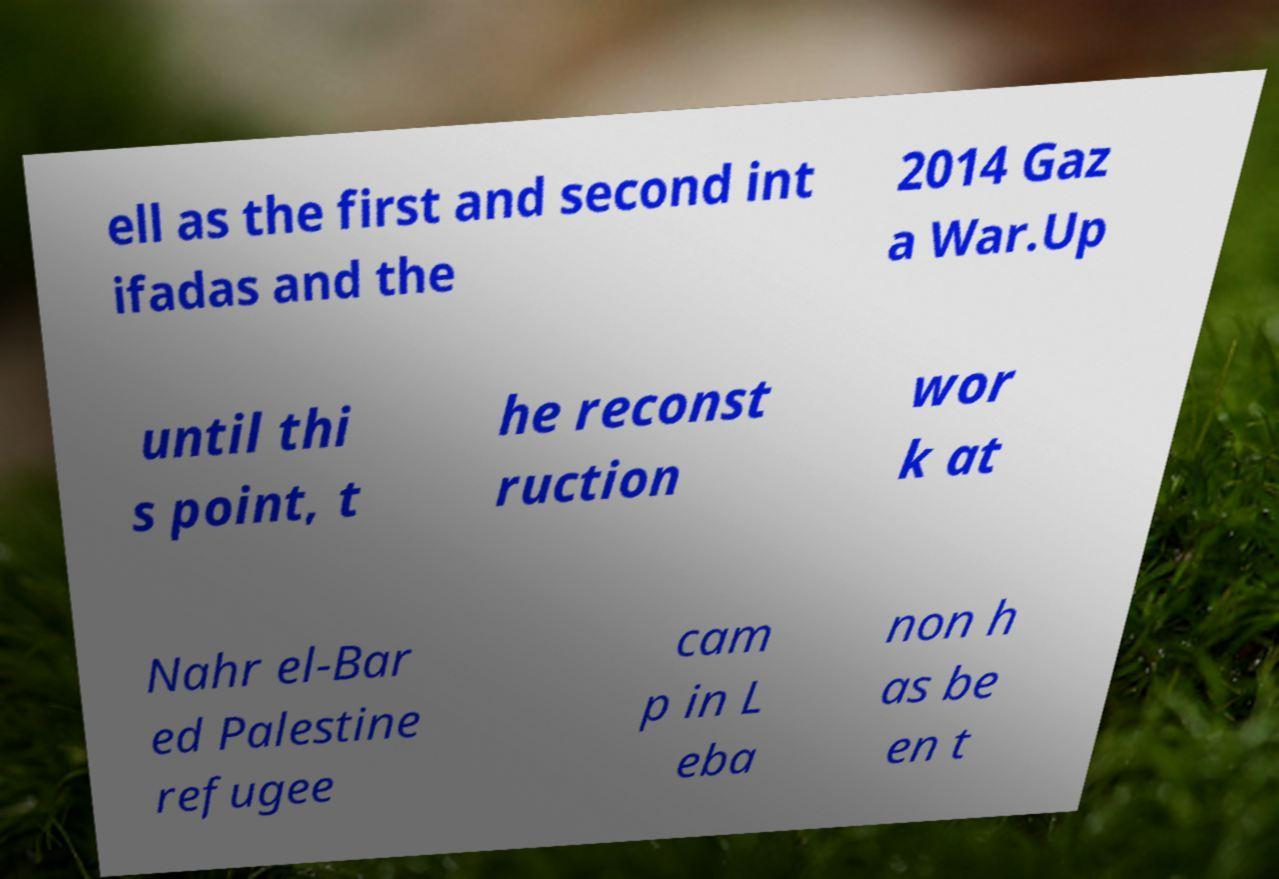Could you assist in decoding the text presented in this image and type it out clearly? ell as the first and second int ifadas and the 2014 Gaz a War.Up until thi s point, t he reconst ruction wor k at Nahr el-Bar ed Palestine refugee cam p in L eba non h as be en t 